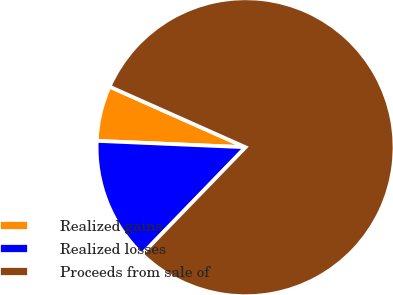Convert chart. <chart><loc_0><loc_0><loc_500><loc_500><pie_chart><fcel>Realized gains<fcel>Realized losses<fcel>Proceeds from sale of<nl><fcel>5.99%<fcel>13.44%<fcel>80.57%<nl></chart> 